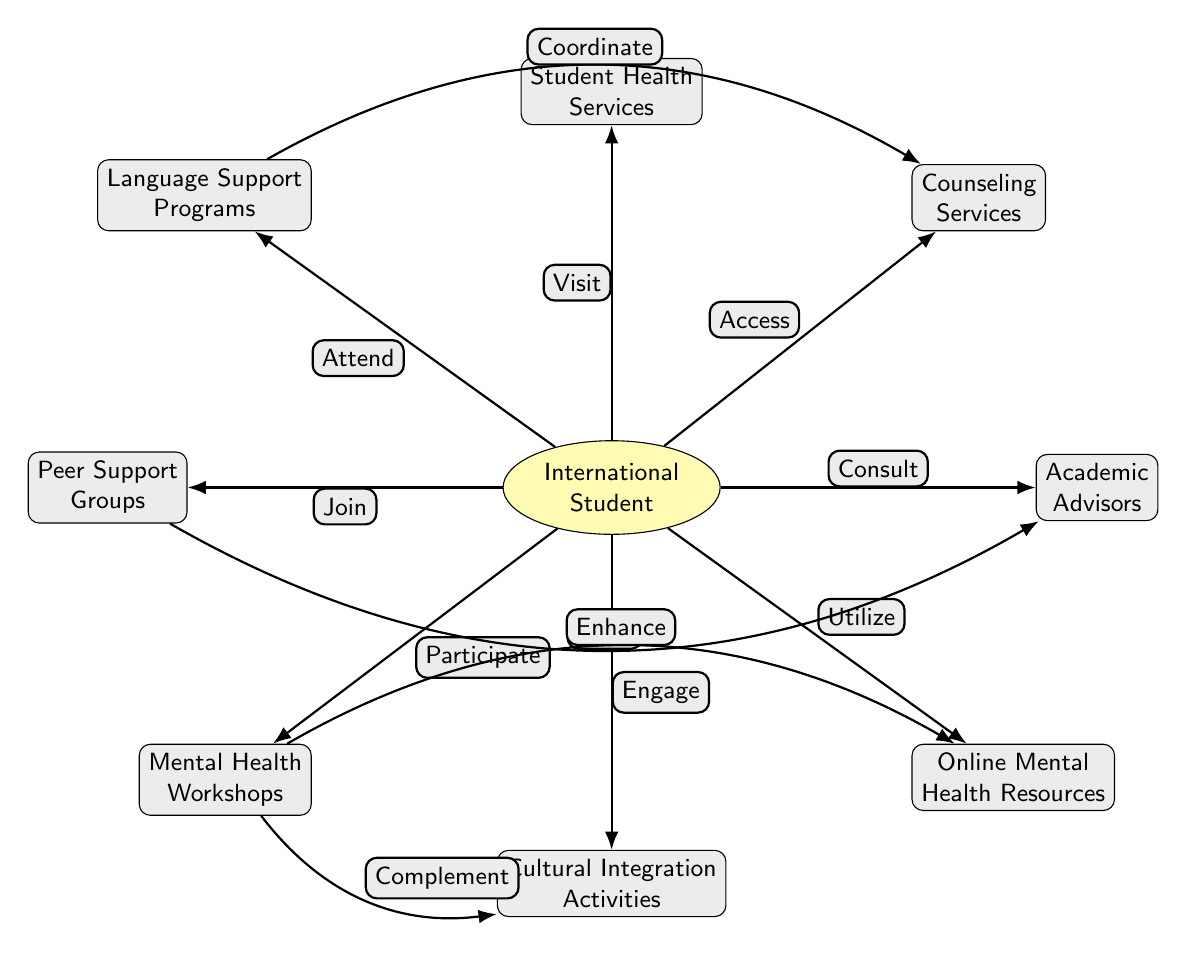What's the central node in the diagram? The central node is the "International Student." It is the main focus of the diagram as it connects to various support systems surrounding it.
Answer: International Student How many support systems are connected to the international student? There are eight support systems connected to the International Student, visible from the edges leading to different nodes in the diagram.
Answer: 8 What is one pathway to get academic assistance? The pathway to get academic assistance is by consulting Academic Advisors. This connection is directly represented by the edge labeled "Consult" leading from the International Student to the Academic Advisors node.
Answer: Consult Which nodes represent social support? The nodes that represent social support are Peer Support Groups and Cultural Integration Activities. These are focused on providing communal and cultural connections for international students.
Answer: Peer Support Groups, Cultural Integration Activities How does the language support program interact with counseling services? The Language Support Programs and Counseling Services are connected through the edge labeled "Coordinate." This indicates that these two support systems work together to assist international students.
Answer: Coordinate Which two systems enhance each other according to the diagram? Mental Health Workshops and Online Mental Health Resources enhance each other. The edge labeled "Enhance" shows this collaborative relationship, indicating that one supports the effectiveness of the other.
Answer: Enhance What type of resources can the international student utilize online? The international student can utilize Online Mental Health Resources. This system provides digital options for mental health support, making it easily accessible.
Answer: Online Mental Health Resources How does peer support relate to academic advising? Peer Support Groups can refer students to Academic Advisors. This signifies a supportive network where peers can guide students to seek further academic assistance as needed.
Answer: Refer 